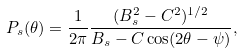<formula> <loc_0><loc_0><loc_500><loc_500>P _ { s } ( \theta ) = \frac { 1 } { 2 \pi } \frac { ( B _ { s } ^ { 2 } - C ^ { 2 } ) ^ { 1 / 2 } } { B _ { s } - C \cos ( 2 \theta - \psi ) } ,</formula> 